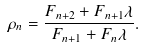<formula> <loc_0><loc_0><loc_500><loc_500>\rho _ { n } = \frac { F _ { n + 2 } + F _ { n + 1 } \lambda } { F _ { n + 1 } + F _ { n } \lambda } .</formula> 